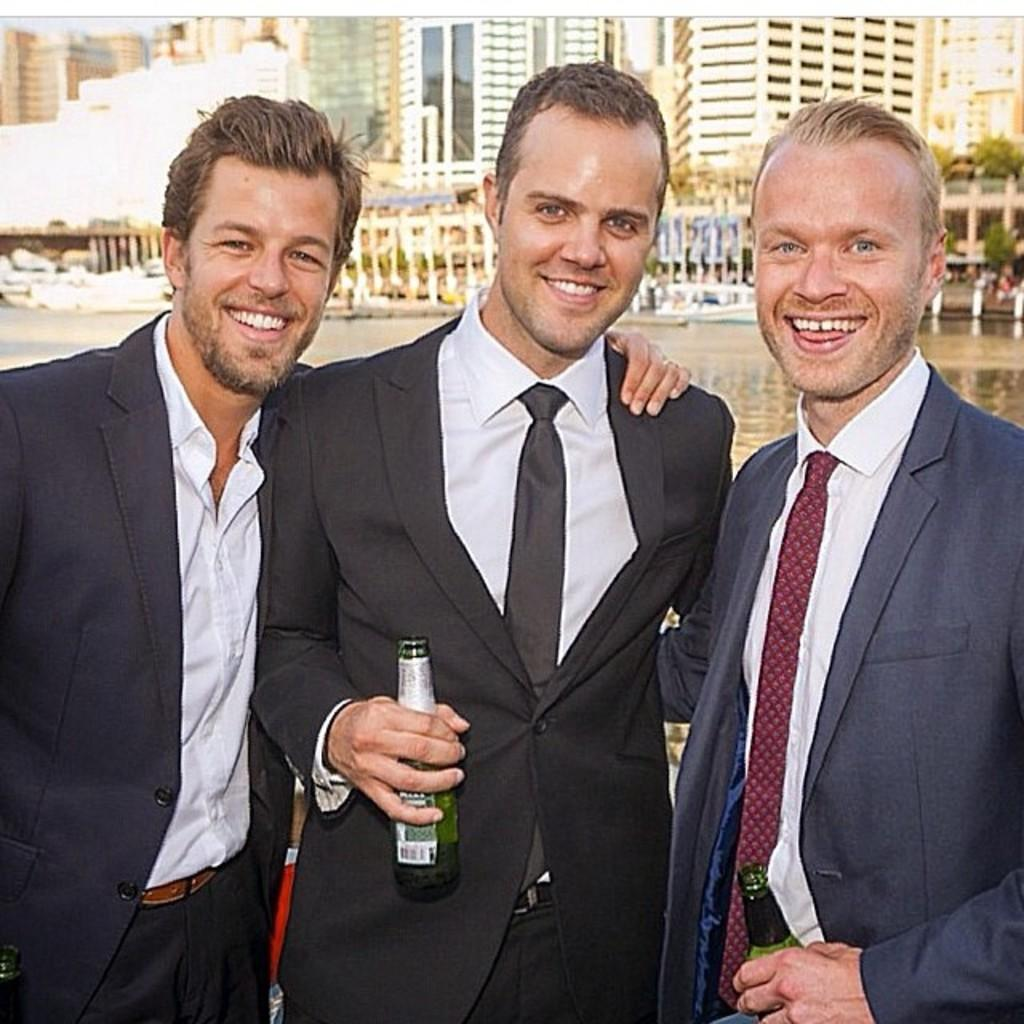How many men are in the image? There are three men standing in the image. What are the men holding in the image? The men are holding bottles. What can be seen in the background of the image? There is a water body, a group of buildings, pillars, trees, and the sky visible in the background. What shape is the icicle hanging from the spy's hat in the image? There is no icicle or spy present in the image. 